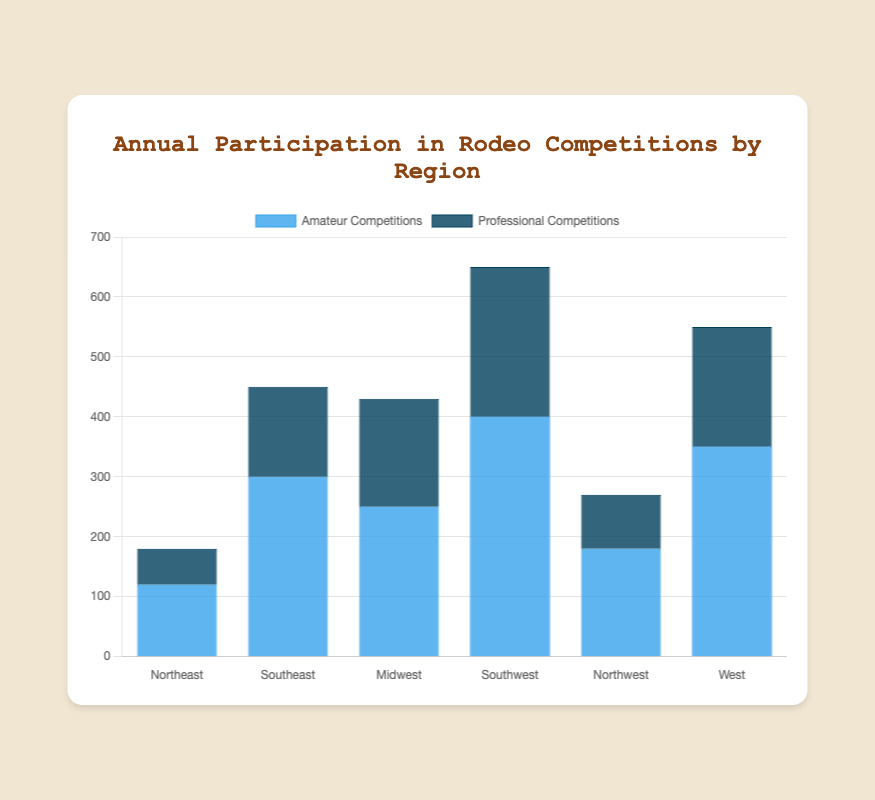Which region has the highest number of amateur competitions? By examining the highest blue bar among all regions, we can identify the Southwest having the highest number of amateur competitions with a value of 400.
Answer: Southwest Which region has the smallest difference between amateur and professional competitions? Calculate the difference for each region and find the smallest one: Northeast: 120 - 60 = 60, Southeast: 300 - 150 = 150, Midwest: 250 - 180 = 70, Southwest: 400 - 250 = 150, Northwest: 180 - 90 = 90, West: 350 - 200 = 150. The smallest difference is in the Northeast with 60.
Answer: Northeast How many total competitions (amateur and professional) are there in the Midwest? Sum the amateur and professional competitions in the Midwest: 250 + 180 = 430.
Answer: 430 Which regions have a higher number of professional competitions compared to the Northeast? Compare the number of professional competitions in other regions to the Northeast (60): Southeast (150), Midwest (180), Southwest (250), Northwest (90), West (200). All these regions have higher numbers.
Answer: Southeast, Midwest, Southwest, Northwest, West What is the average number of amateur competitions across all regions? Add up the amateur competitions from all regions and divide by the number of regions: (120 + 300 + 250 + 400 + 180 + 350) / 6 = 1600 / 6 ≈ 267.
Answer: 267 Which region's professional competitions are closest in number to the West's professional competitions? Compare all regions' professional competitions to the West (200): Northeast (60), Southeast (150), Midwest (180), Southwest (250), Northwest (90). The closest is Midwest with 180.
Answer: Midwest Which region has the second-highest total number of amateur and professional competitions combined? Calculate the total for each region: Northeast: 120 + 60 = 180, Southeast: 300 + 150 = 450, Midwest: 250 + 180 = 430, Southwest: 400 + 250 = 650, Northwest: 180 + 90 = 270, West: 350 + 200 = 550. The second-highest total is the West with 550.
Answer: West Which regions have fewer than 200 professional competitions? Check each region's professional competitions: Northeast (60), Southeast (150), Midwest (180), Southwest (250), Northwest (90), West (200). Regions with fewer than 200 are Northeast, Southeast, Midwest, and Northwest.
Answer: Northeast, Southeast, Midwest, Northwest 